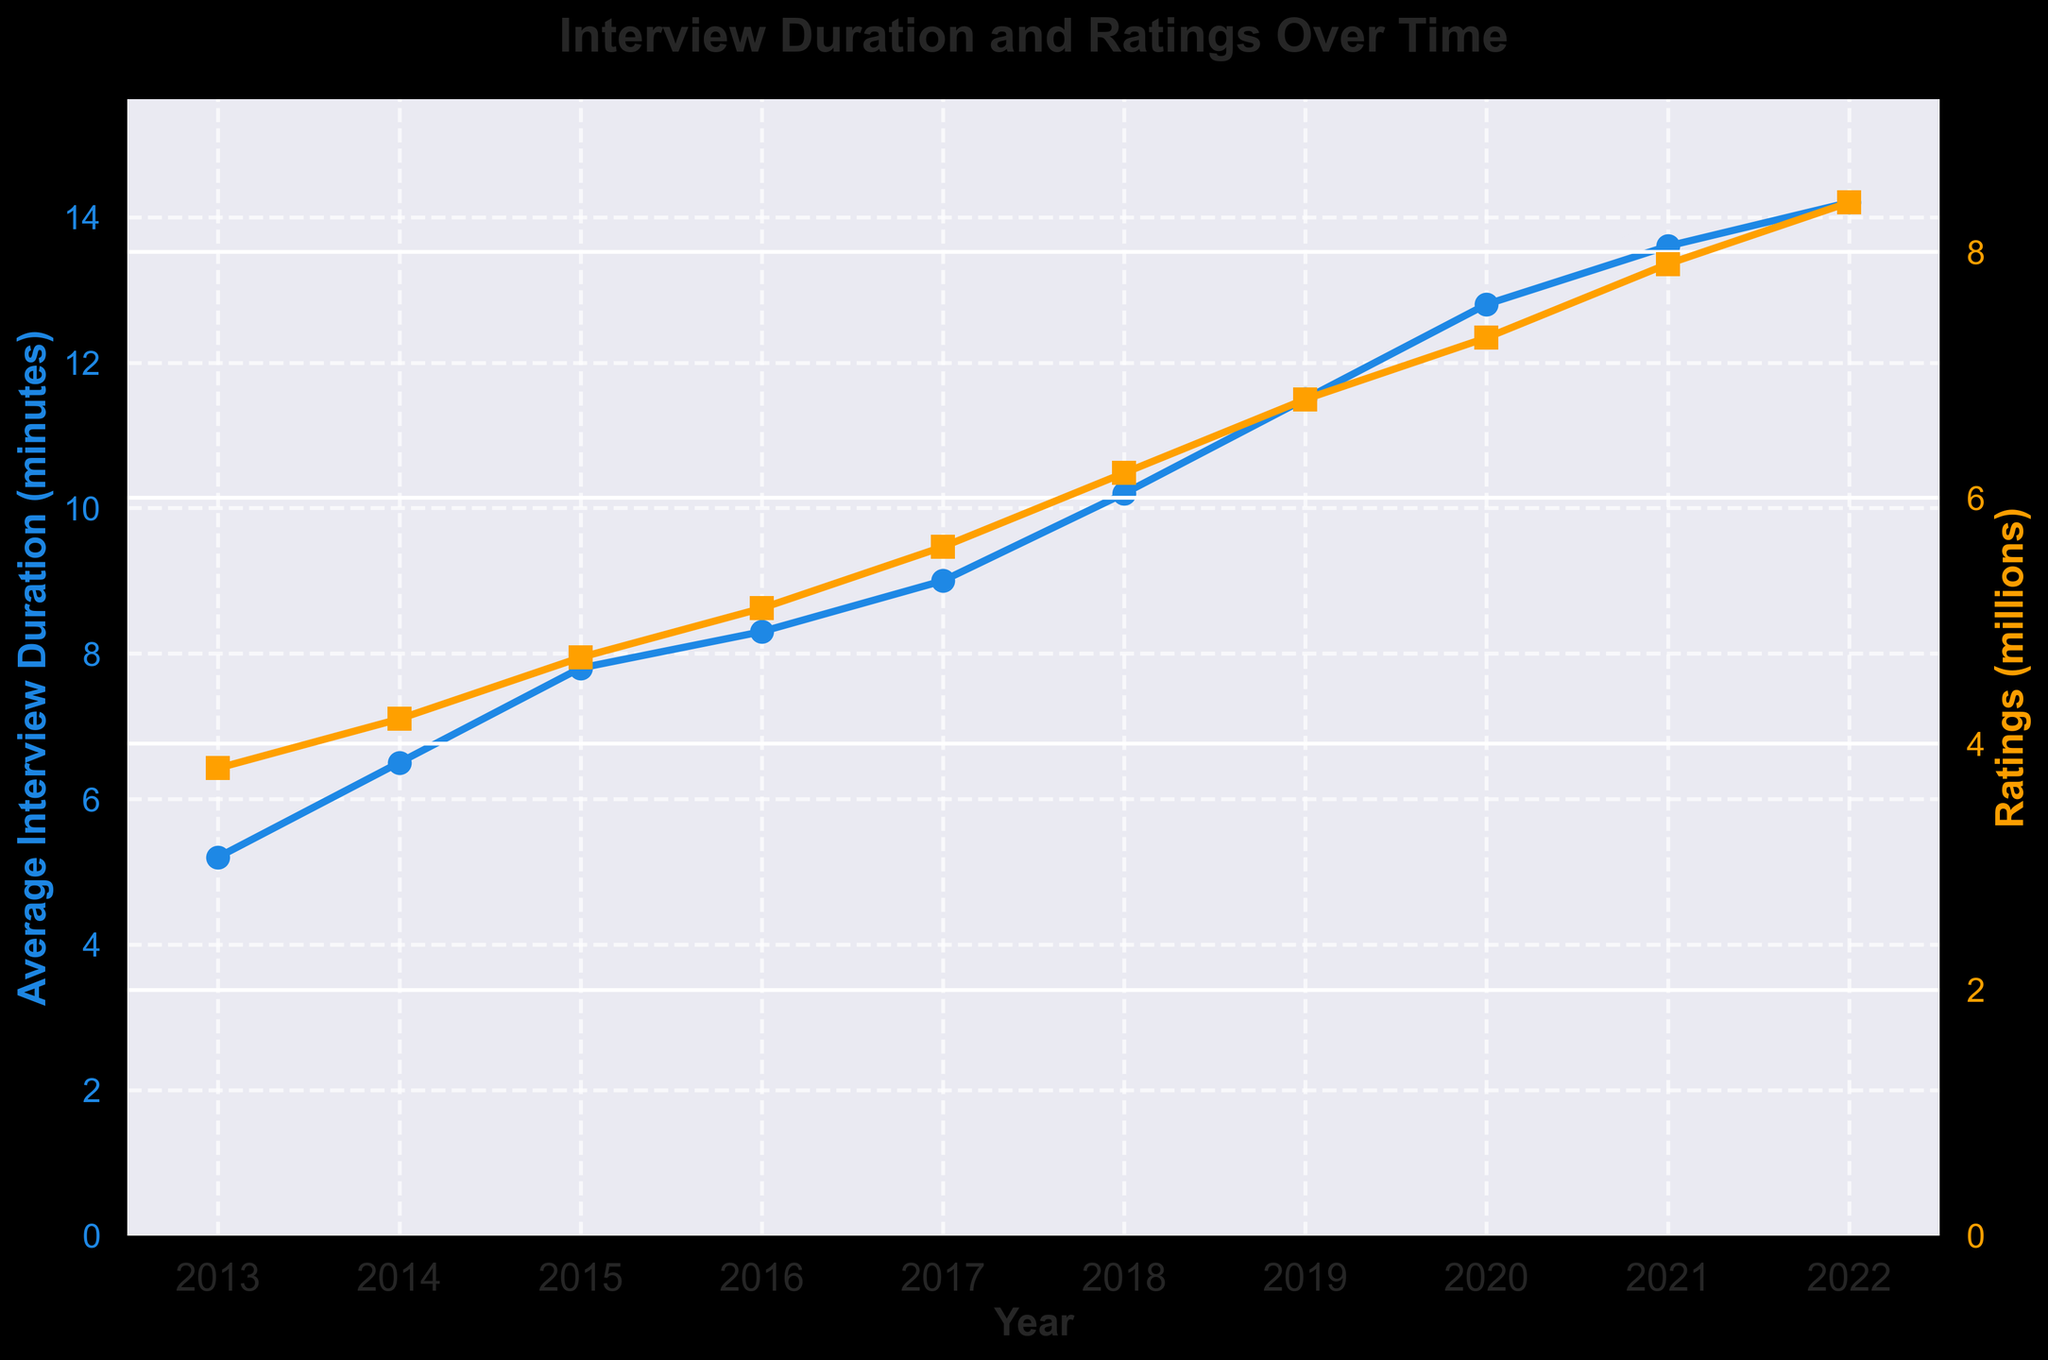what is the average value of group A? Explanation: There are 5 data points in group A, sum them up is (34 + 45 + 23 + 56 + 12) = 170, so the average is 170/5 = 34
Answer: 34 what is the difference in ratings between 2018 and 2020? Explanation: The ratings in 2018 are 6.2 million and in 2020 are 7.3 million. The difference is 7.3 - 6.2 = 1.1 million
Answer: 1.1 million which year had the highest average interview duration? Explanation: The highest average interview duration is 14.2 minutes in 2022
Answer: 2022 what is the trend in average interview duration from 2013 to 2022? Explanation: By observing the line chart, it's clear that the average interview duration shows a continuously increasing trend from 5.2 minutes in 2013 to 14.2 minutes in 2022
Answer: Increasing compare the ratings in 2021 to those in 2013. What can be said about them? Explanation: The ratings in 2013 are 3.8 million and in 2021 are 7.9 million. The ratings in 2021 are significantly higher than those in 2013
Answer: 2021 ratings are higher how much did the average interview duration increase from 2013 to 2017? Explanation: From the figure, the average interview duration in 2013 is 5.2 minutes and in 2017 is 9.0 minutes. The increase is 9.0 - 5.2 = 3.8 minutes
Answer: 3.8 minutes what is the overall relationship between average interview duration and ratings over time? Explanation: As observed in the figure, both the average interview duration and ratings generally increase over time, indicating a positive relationship
Answer: Positive relationship in which year did the ratings first exceed 7 million? Explanation: From the data in the figure, the ratings first exceed 7 million in 2020, reaching 7.3 million
Answer: 2020 calculate the total increase in ratings from 2013 to 2022. Explanation: The ratings in 2013 are 3.8 million and in 2022 are 8.4 million. The total increase is 8.4 - 3.8 = 4.6 million
Answer: 4.6 million 